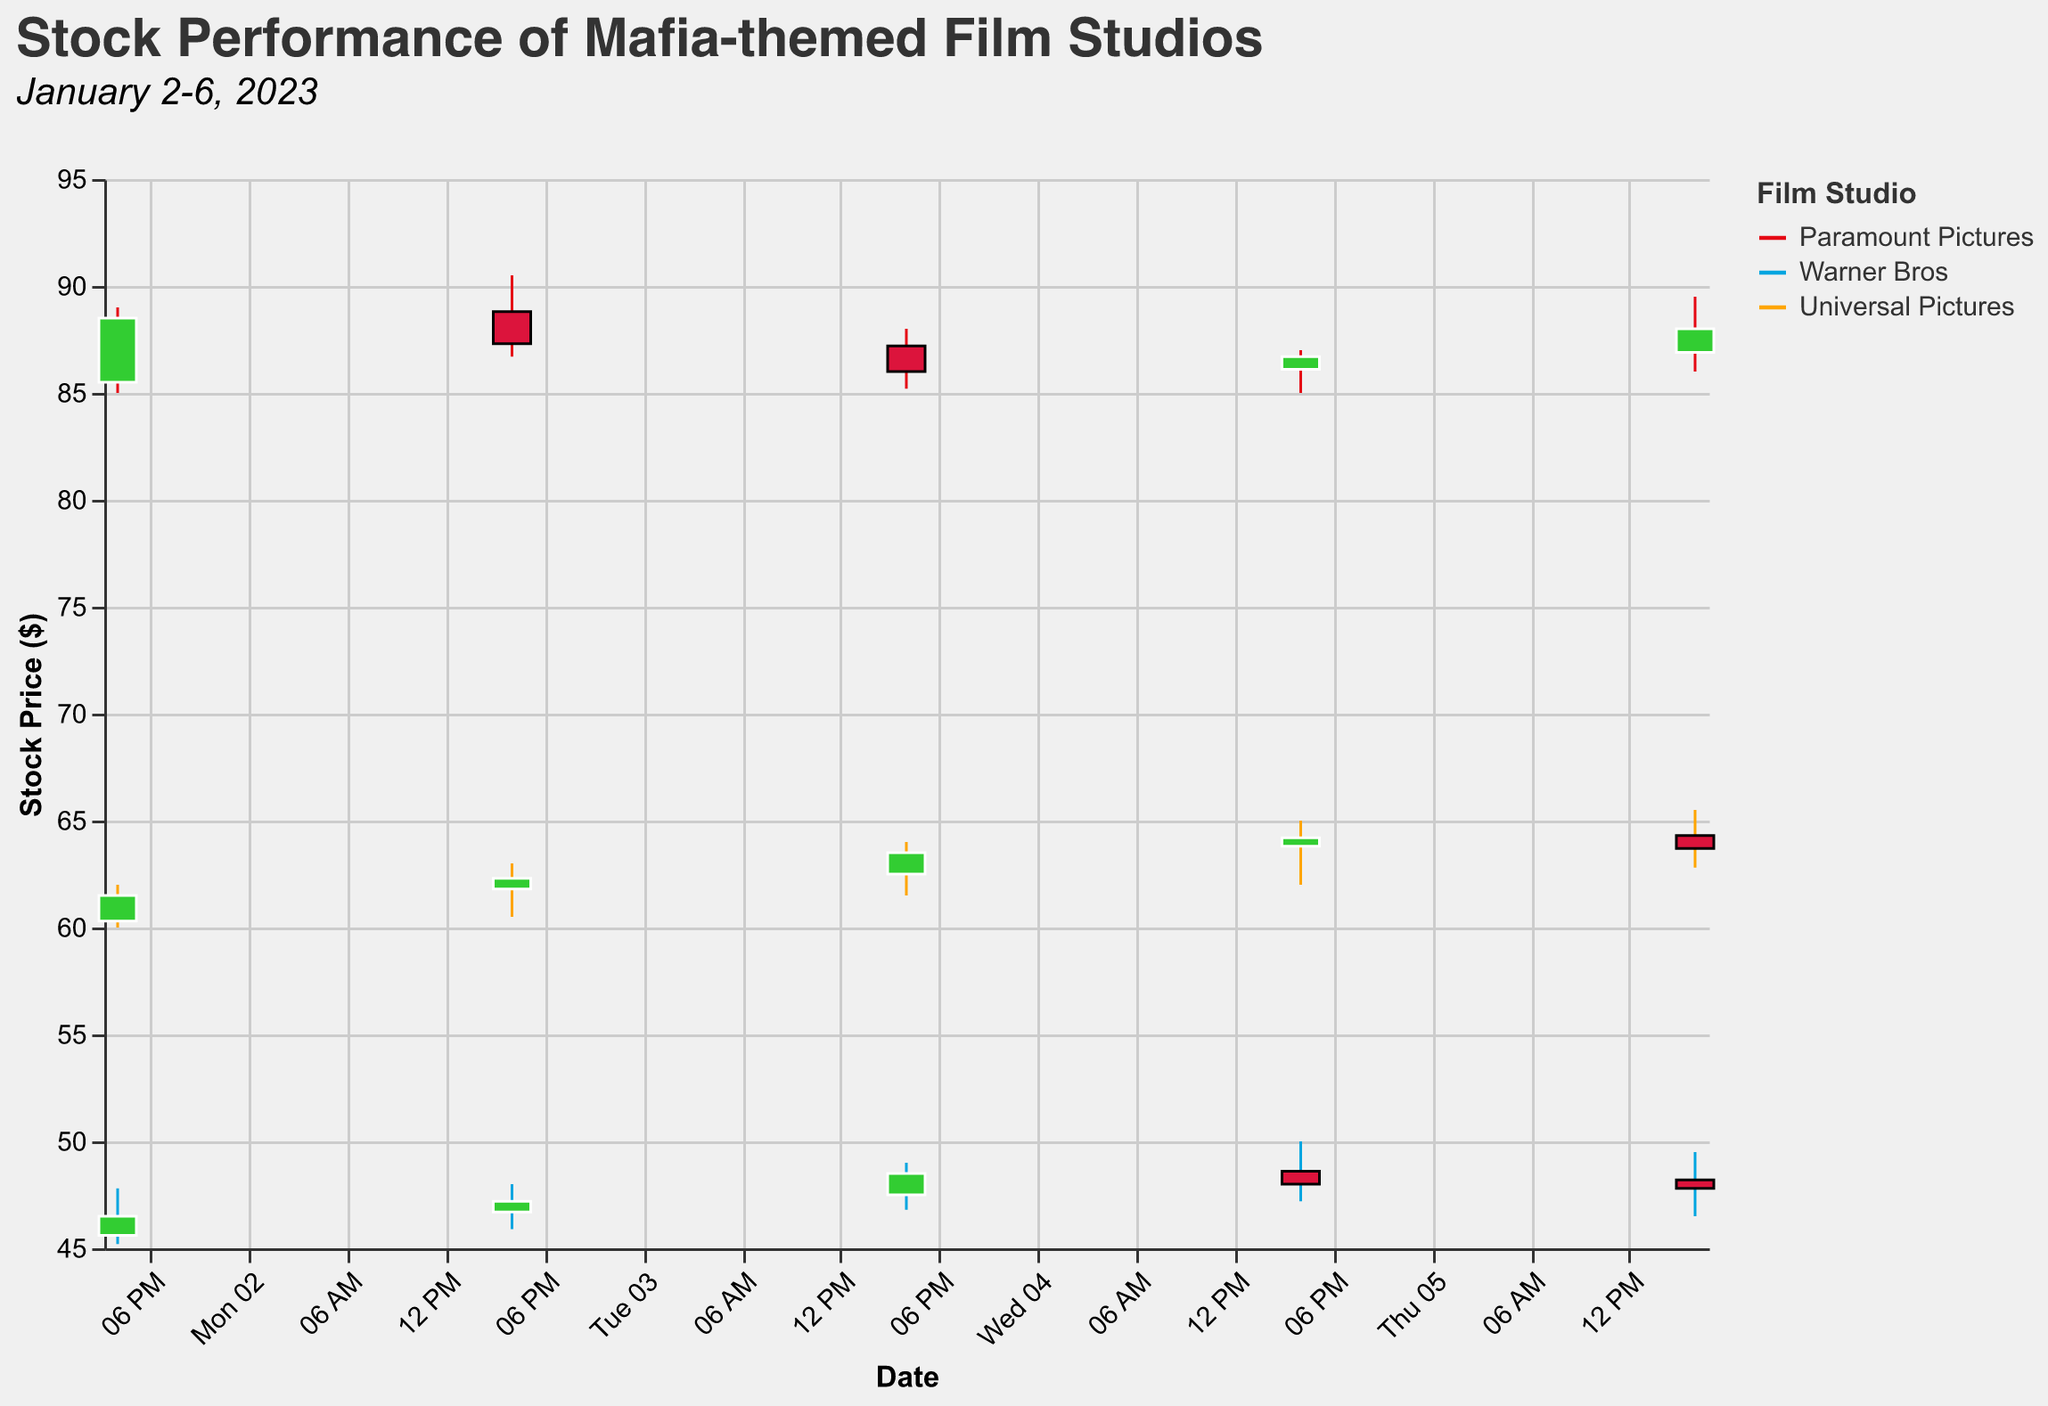What's the title of the figure, and what are the dates covered in the subtitle? The title of the figure and subtitle provide a quick context of what the chart is about and the time period it covers. The title is typically at the top of the chart, and the subtitle is usually found below the title.
Answer: "Stock Performance of Mafia-themed Film Studios", "January 2-6, 2023" Which film studio had the highest closing price on January 4, 2023? Check the candlestick representing January 4, 2023 for each film studio, and look at the closing prices indicated by the position of the Close marker. Compare these values to identify the highest one.
Answer: Universal Pictures What is the difference between the highest and lowest stock prices for Warner Bros on January 5, 2023? Look at the candlestick for Warner Bros on January 5, 2023. The highest price corresponds to the top of the upper wick, while the lowest price is at the bottom of the lower wick. Subtract the lowest price from the highest price.
Answer: 2.80 Did Universal Pictures have an increase or decrease in closing price from January 5 to January 6, 2023? Compare the closing prices for Universal Pictures on January 5 and January 6, 2023 by looking at the position of the Close markers for these dates. An increase means the marker on January 6 is higher than on January 5; a decrease means it is lower.
Answer: Decrease Which studio had the highest volume of trades on any single day, and what was the volume? Look for the day with the highest Volume value by observing the Volume information provided in the tooltip. Compare these values across all studios and all days to find the highest one.
Answer: Warner Bros, 320000 What was the lowest opening price for Paramount Pictures during January 2-6, 2023? Look at the opening prices for all days (January 2-6, 2023) for Paramount Pictures represented on the candlestick plot. Identify the smallest value among them.
Answer: 85.50 Between Warner Bros and Universal Pictures, which studio had a higher closing price on January 3, 2023? Check the closing prices for Warner Bros and Universal Pictures on January 3, 2023. Compare these values to determine which one is higher.
Answer: Universal Pictures What was the average closing price of Paramount Pictures from January 2 to January 6, 2023? Sum up the closing prices for Paramount Pictures from January 2 to January 6, 2023, and divide the total by the number of days (which is 5). Calculate the mathematical average.
Answer: (88.50+87.30+86.00+86.70+88.00) / 5 = 87.30 